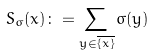<formula> <loc_0><loc_0><loc_500><loc_500>S _ { \sigma } ( x ) \colon = \sum _ { y \in \overline { \{ x \} } } \sigma ( y )</formula> 